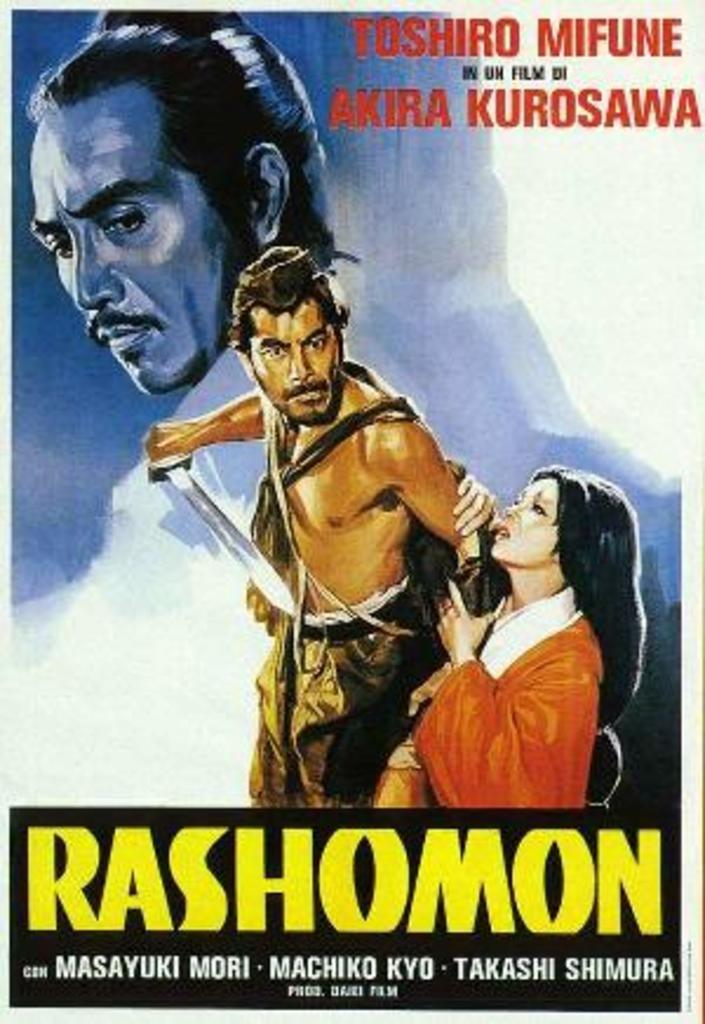<image>
Provide a brief description of the given image. A Rashomon movie poster shows a man with a large knife. 